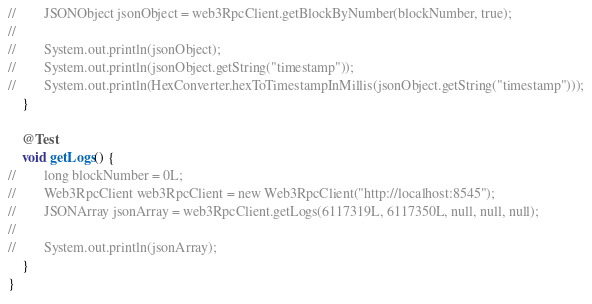<code> <loc_0><loc_0><loc_500><loc_500><_Java_>//        JSONObject jsonObject = web3RpcClient.getBlockByNumber(blockNumber, true);
//
//        System.out.println(jsonObject);
//        System.out.println(jsonObject.getString("timestamp"));
//        System.out.println(HexConverter.hexToTimestampInMillis(jsonObject.getString("timestamp")));
    }

    @Test
    void getLogs() {
//        long blockNumber = 0L;
//        Web3RpcClient web3RpcClient = new Web3RpcClient("http://localhost:8545");
//        JSONArray jsonArray = web3RpcClient.getLogs(6117319L, 6117350L, null, null, null);
//
//        System.out.println(jsonArray);
    }
}</code> 